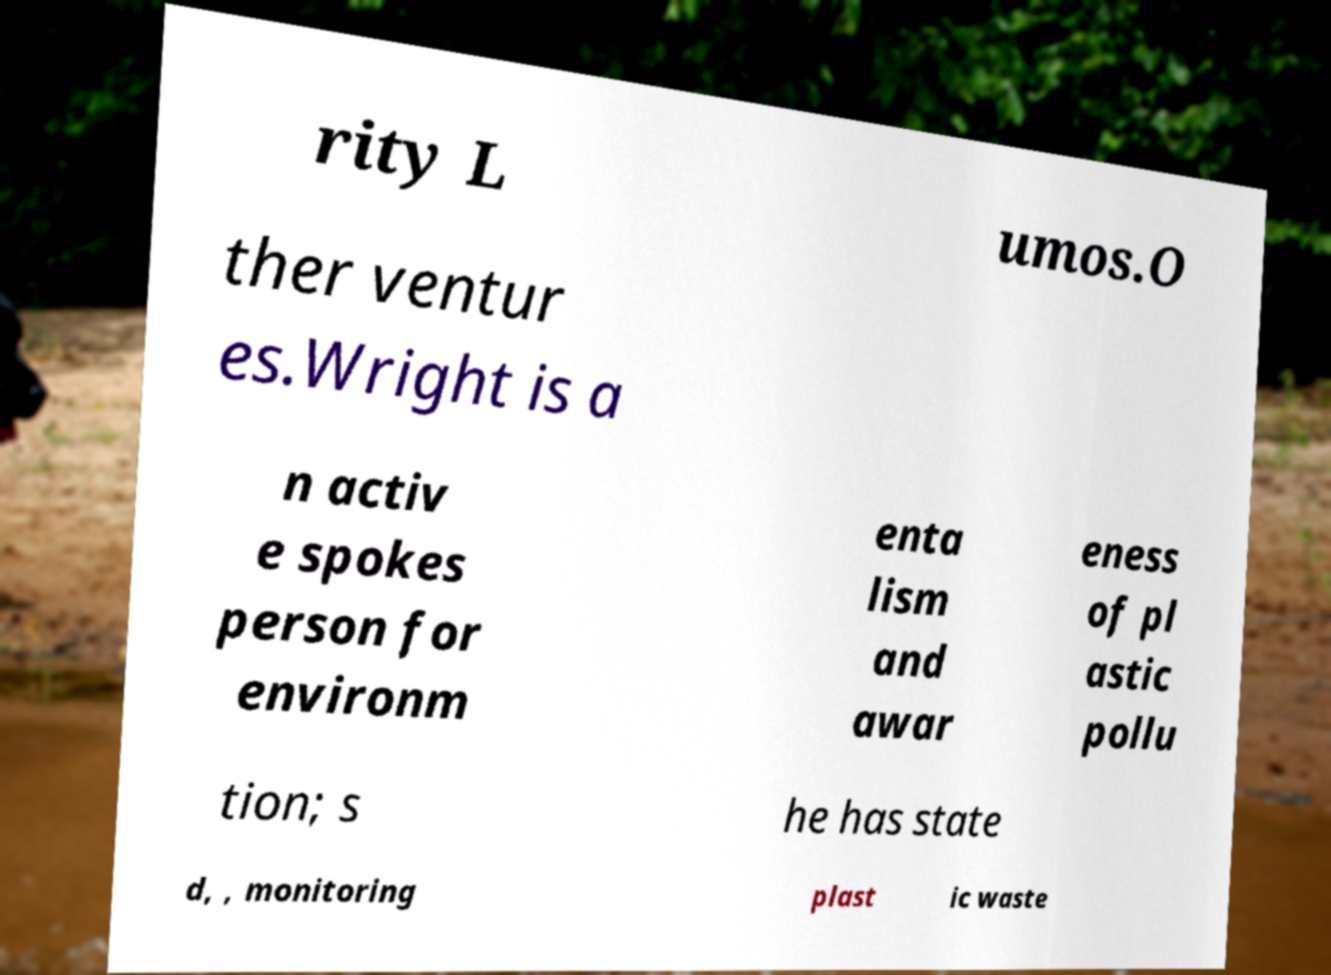I need the written content from this picture converted into text. Can you do that? rity L umos.O ther ventur es.Wright is a n activ e spokes person for environm enta lism and awar eness of pl astic pollu tion; s he has state d, , monitoring plast ic waste 